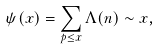Convert formula to latex. <formula><loc_0><loc_0><loc_500><loc_500>\psi ( x ) = \sum _ { p \leq x } \Lambda ( n ) \sim x ,</formula> 